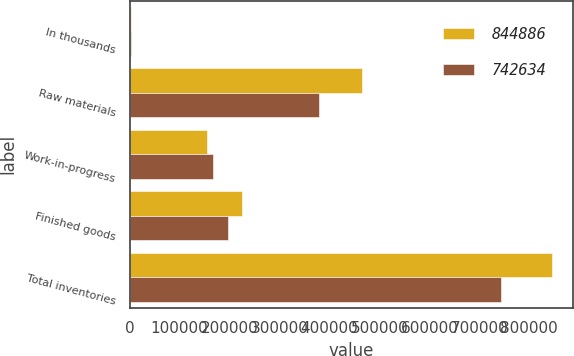<chart> <loc_0><loc_0><loc_500><loc_500><stacked_bar_chart><ecel><fcel>In thousands<fcel>Raw materials<fcel>Work-in-progress<fcel>Finished goods<fcel>Total inventories<nl><fcel>844886<fcel>2018<fcel>465873<fcel>154485<fcel>224528<fcel>844886<nl><fcel>742634<fcel>2017<fcel>378481<fcel>167390<fcel>196763<fcel>742634<nl></chart> 